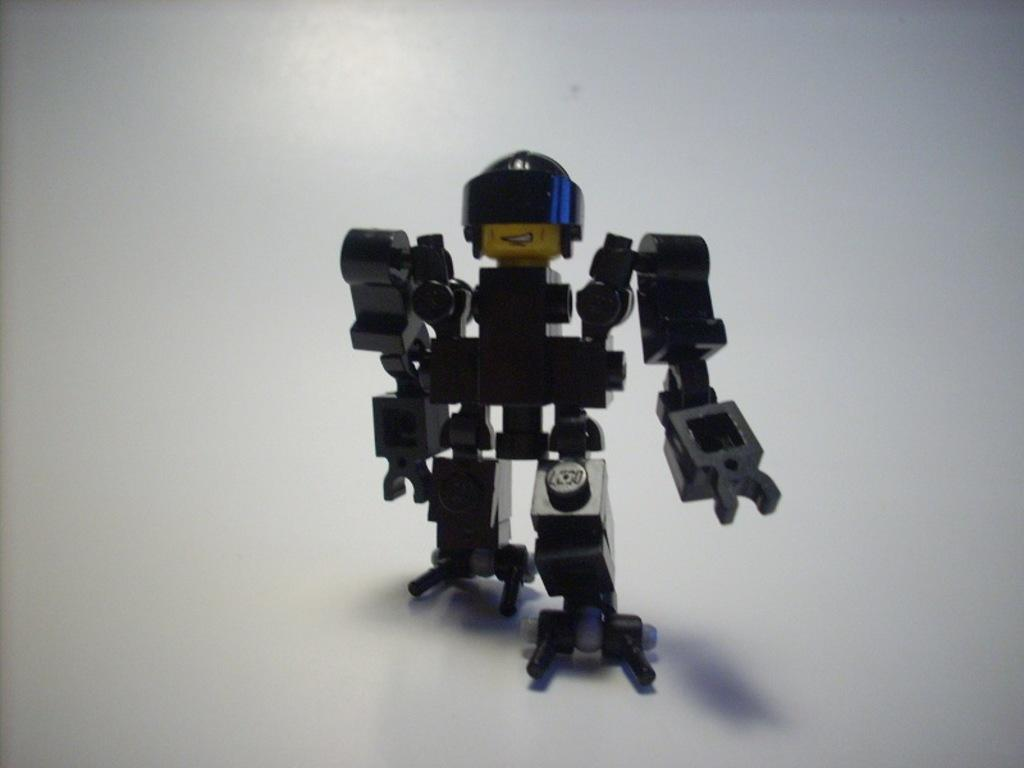What object is the main subject of the image? There is a toy in the image. Where is the toy placed in the image? The toy is on a white platform. What color is the background of the image? The background of the image is white. How many trees can be seen in the image? There are no trees present in the image. What level of difficulty does the toy provide in the image? The image does not provide any information about the toy's level of difficulty. 